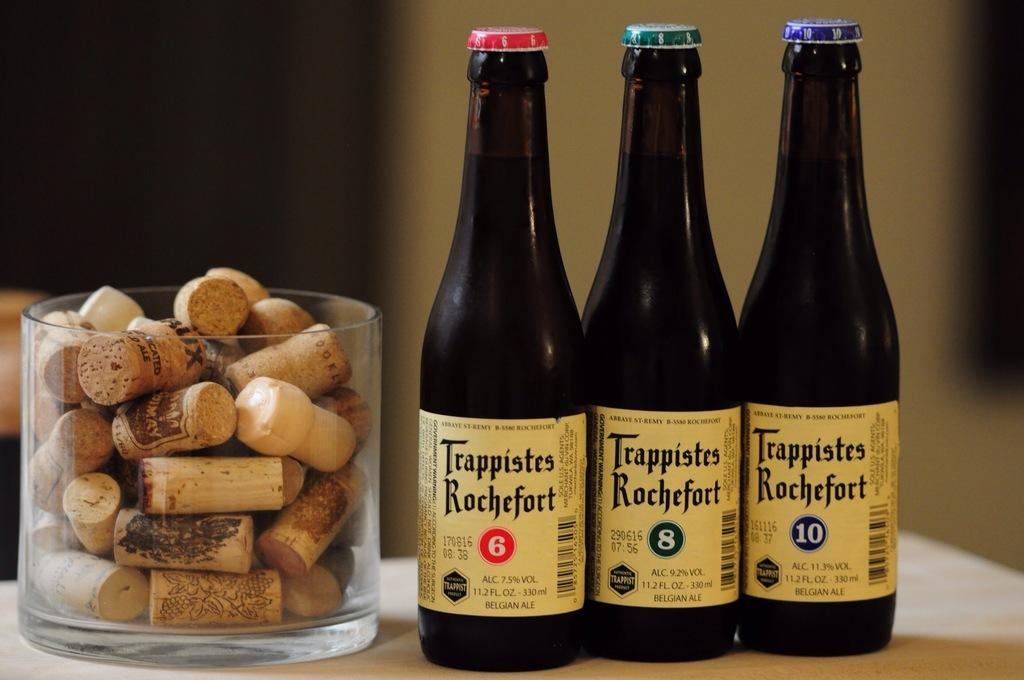<image>
Relay a brief, clear account of the picture shown. Three bottles of Trappistes Rochefort next to a jar of corks. 